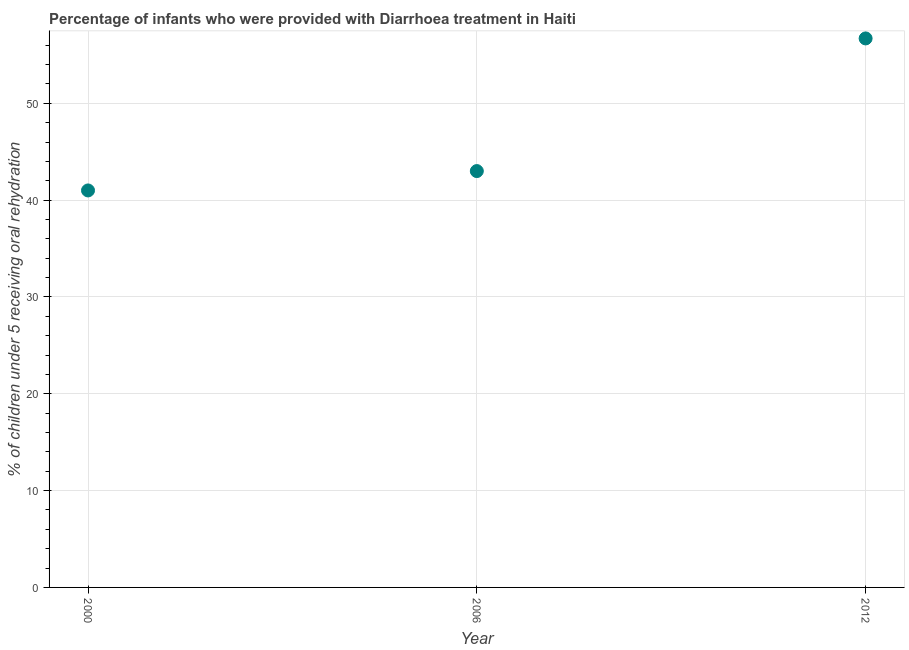Across all years, what is the maximum percentage of children who were provided with treatment diarrhoea?
Provide a short and direct response. 56.7. Across all years, what is the minimum percentage of children who were provided with treatment diarrhoea?
Keep it short and to the point. 41. In which year was the percentage of children who were provided with treatment diarrhoea minimum?
Make the answer very short. 2000. What is the sum of the percentage of children who were provided with treatment diarrhoea?
Ensure brevity in your answer.  140.7. What is the difference between the percentage of children who were provided with treatment diarrhoea in 2000 and 2012?
Keep it short and to the point. -15.7. What is the average percentage of children who were provided with treatment diarrhoea per year?
Provide a short and direct response. 46.9. What is the median percentage of children who were provided with treatment diarrhoea?
Offer a terse response. 43. In how many years, is the percentage of children who were provided with treatment diarrhoea greater than 46 %?
Your response must be concise. 1. What is the ratio of the percentage of children who were provided with treatment diarrhoea in 2000 to that in 2006?
Offer a very short reply. 0.95. Is the percentage of children who were provided with treatment diarrhoea in 2006 less than that in 2012?
Ensure brevity in your answer.  Yes. What is the difference between the highest and the second highest percentage of children who were provided with treatment diarrhoea?
Make the answer very short. 13.7. What is the difference between the highest and the lowest percentage of children who were provided with treatment diarrhoea?
Your answer should be compact. 15.7. What is the difference between two consecutive major ticks on the Y-axis?
Provide a succinct answer. 10. Are the values on the major ticks of Y-axis written in scientific E-notation?
Make the answer very short. No. What is the title of the graph?
Offer a terse response. Percentage of infants who were provided with Diarrhoea treatment in Haiti. What is the label or title of the X-axis?
Ensure brevity in your answer.  Year. What is the label or title of the Y-axis?
Make the answer very short. % of children under 5 receiving oral rehydration. What is the % of children under 5 receiving oral rehydration in 2000?
Your response must be concise. 41. What is the % of children under 5 receiving oral rehydration in 2006?
Your answer should be very brief. 43. What is the % of children under 5 receiving oral rehydration in 2012?
Your response must be concise. 56.7. What is the difference between the % of children under 5 receiving oral rehydration in 2000 and 2006?
Keep it short and to the point. -2. What is the difference between the % of children under 5 receiving oral rehydration in 2000 and 2012?
Provide a succinct answer. -15.7. What is the difference between the % of children under 5 receiving oral rehydration in 2006 and 2012?
Your answer should be very brief. -13.7. What is the ratio of the % of children under 5 receiving oral rehydration in 2000 to that in 2006?
Provide a short and direct response. 0.95. What is the ratio of the % of children under 5 receiving oral rehydration in 2000 to that in 2012?
Your answer should be very brief. 0.72. What is the ratio of the % of children under 5 receiving oral rehydration in 2006 to that in 2012?
Your response must be concise. 0.76. 